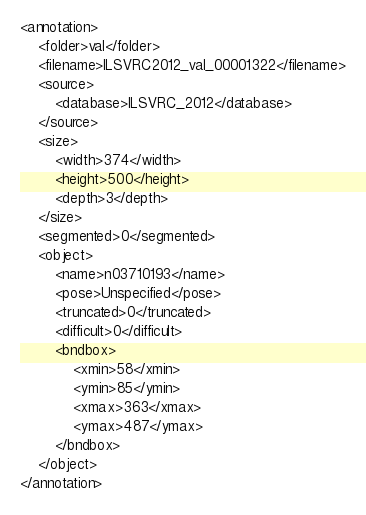Convert code to text. <code><loc_0><loc_0><loc_500><loc_500><_XML_><annotation>
	<folder>val</folder>
	<filename>ILSVRC2012_val_00001322</filename>
	<source>
		<database>ILSVRC_2012</database>
	</source>
	<size>
		<width>374</width>
		<height>500</height>
		<depth>3</depth>
	</size>
	<segmented>0</segmented>
	<object>
		<name>n03710193</name>
		<pose>Unspecified</pose>
		<truncated>0</truncated>
		<difficult>0</difficult>
		<bndbox>
			<xmin>58</xmin>
			<ymin>85</ymin>
			<xmax>363</xmax>
			<ymax>487</ymax>
		</bndbox>
	</object>
</annotation></code> 